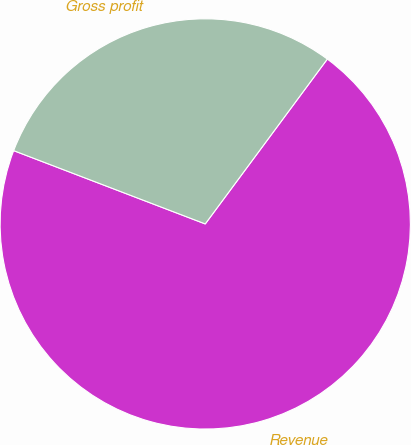Convert chart. <chart><loc_0><loc_0><loc_500><loc_500><pie_chart><fcel>Revenue<fcel>Gross profit<nl><fcel>70.67%<fcel>29.33%<nl></chart> 